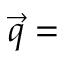Convert formula to latex. <formula><loc_0><loc_0><loc_500><loc_500>\vec { q } =</formula> 